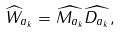Convert formula to latex. <formula><loc_0><loc_0><loc_500><loc_500>\widehat { W } _ { a _ { k } } = \widehat { M _ { a _ { k } } } \widehat { D _ { a _ { k } } } ,</formula> 